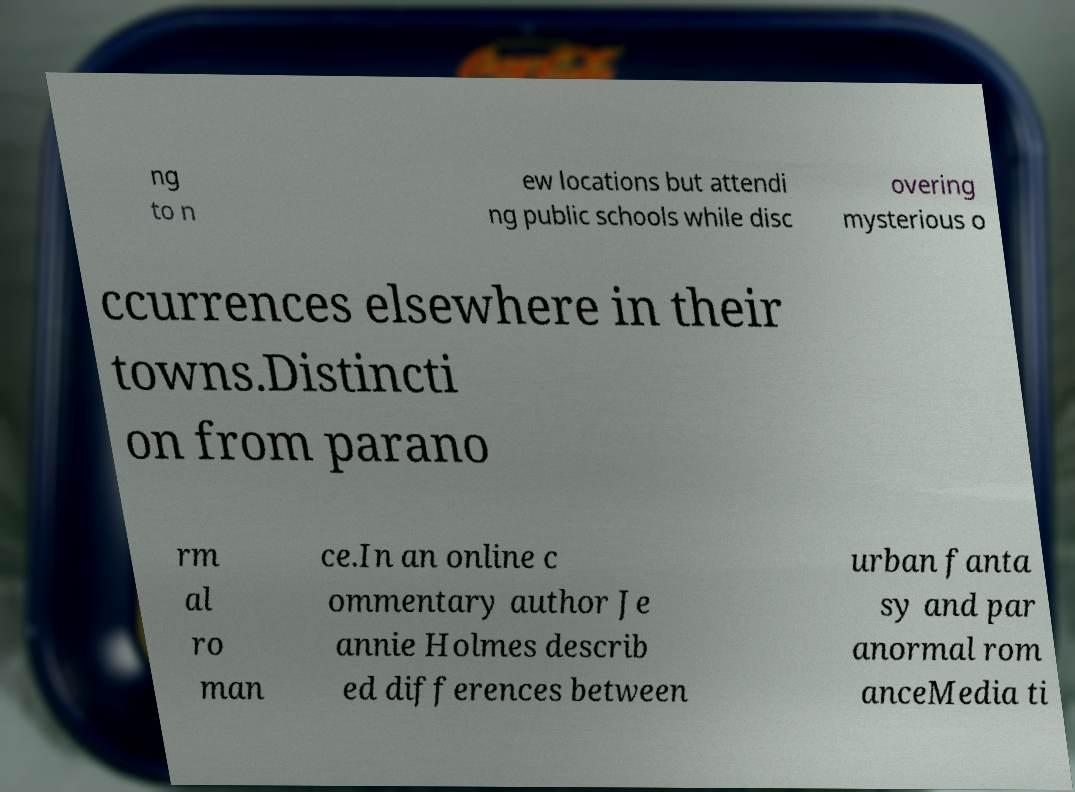Please read and relay the text visible in this image. What does it say? ng to n ew locations but attendi ng public schools while disc overing mysterious o ccurrences elsewhere in their towns.Distincti on from parano rm al ro man ce.In an online c ommentary author Je annie Holmes describ ed differences between urban fanta sy and par anormal rom anceMedia ti 